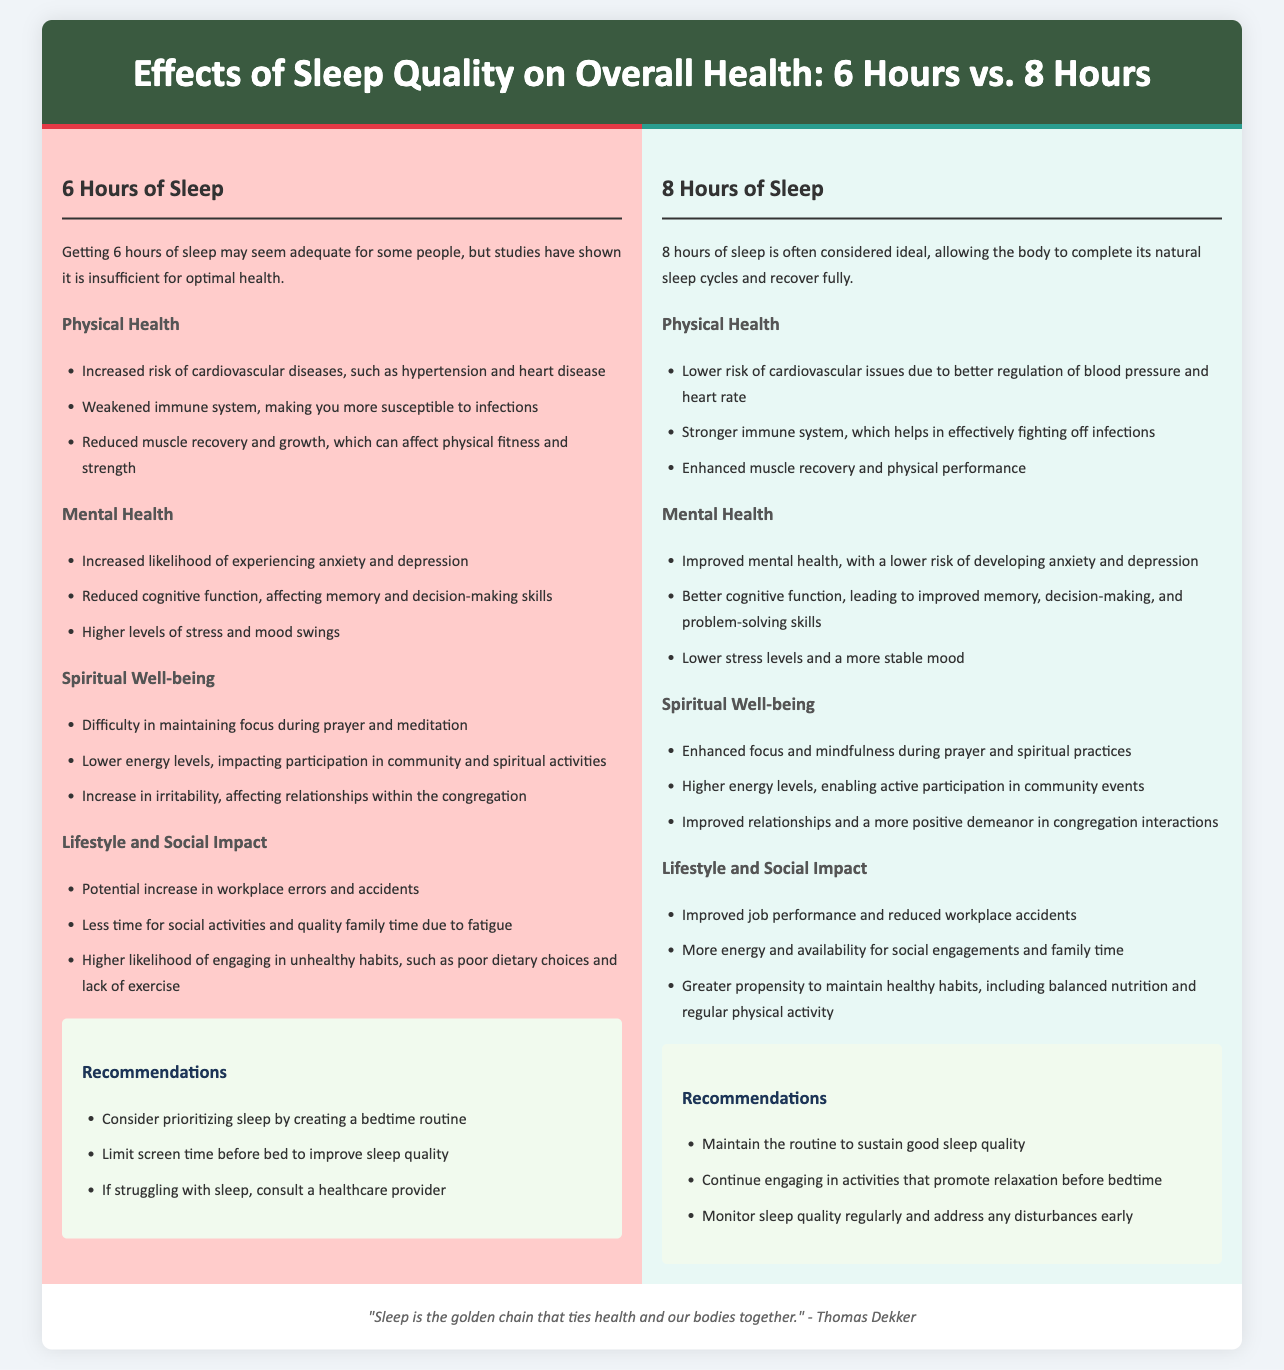what are the risks associated with 6 hours of sleep? The document lists increased risk of cardiovascular diseases, weakened immune system, and reduced muscle recovery.
Answer: cardiovascular diseases, weakened immune system, reduced muscle recovery how many hours of sleep is considered ideal? The document asserts that 8 hours of sleep is often considered ideal for recovery and completing natural sleep cycles.
Answer: 8 hours what is one recommendation for improving sleep quality? Both sections provide recommendations, and one recommendation is to limit screen time before bed.
Answer: limit screen time before bed how does 8 hours of sleep affect mental health? The document states that 8 hours of sleep improves mental health with a lower risk of anxiety and depression.
Answer: lower risk of anxiety and depression what is a benefit of 8 hours of sleep regarding physical performance? The document highlights enhanced muscle recovery and physical performance as a benefit of 8 hours of sleep.
Answer: enhanced muscle recovery and physical performance how does 6 hours of sleep impact spiritual well-being? The document mentions difficulty in maintaining focus during prayer and meditation as an impact of 6 hours of sleep on spiritual well-being.
Answer: difficulty in maintaining focus during prayer and meditation what is the main theme of the infographic? The overarching theme is to compare the effects of sleep quality on overall health between 6 hours and 8 hours of sleep.
Answer: effects of sleep quality on overall health which group is more likely to engage in unhealthy habits? The document indicates that those getting 6 hours of sleep are more likely to engage in unhealthy habits.
Answer: those getting 6 hours of sleep 